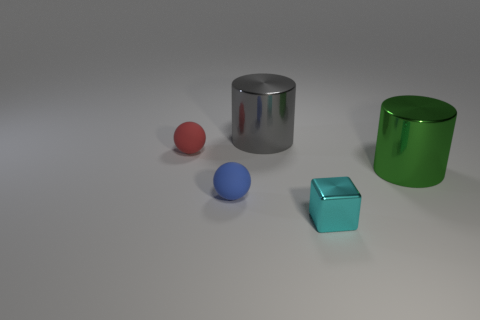Add 3 small blue spheres. How many objects exist? 8 Subtract all red balls. How many balls are left? 1 Subtract all blocks. How many objects are left? 4 Subtract all green balls. Subtract all purple cylinders. How many balls are left? 2 Subtract all tiny green metal objects. Subtract all small metallic cubes. How many objects are left? 4 Add 2 big gray objects. How many big gray objects are left? 3 Add 4 large shiny things. How many large shiny things exist? 6 Subtract 0 yellow blocks. How many objects are left? 5 Subtract 1 cubes. How many cubes are left? 0 